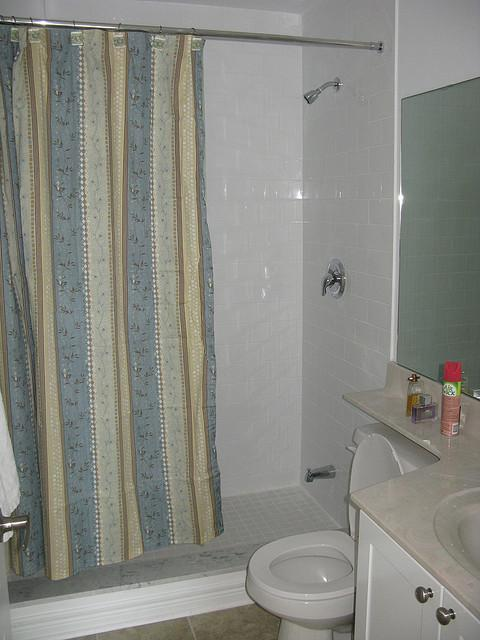What is in the can on the counter? Please explain your reasoning. air freshener. The can is an air freshener. 